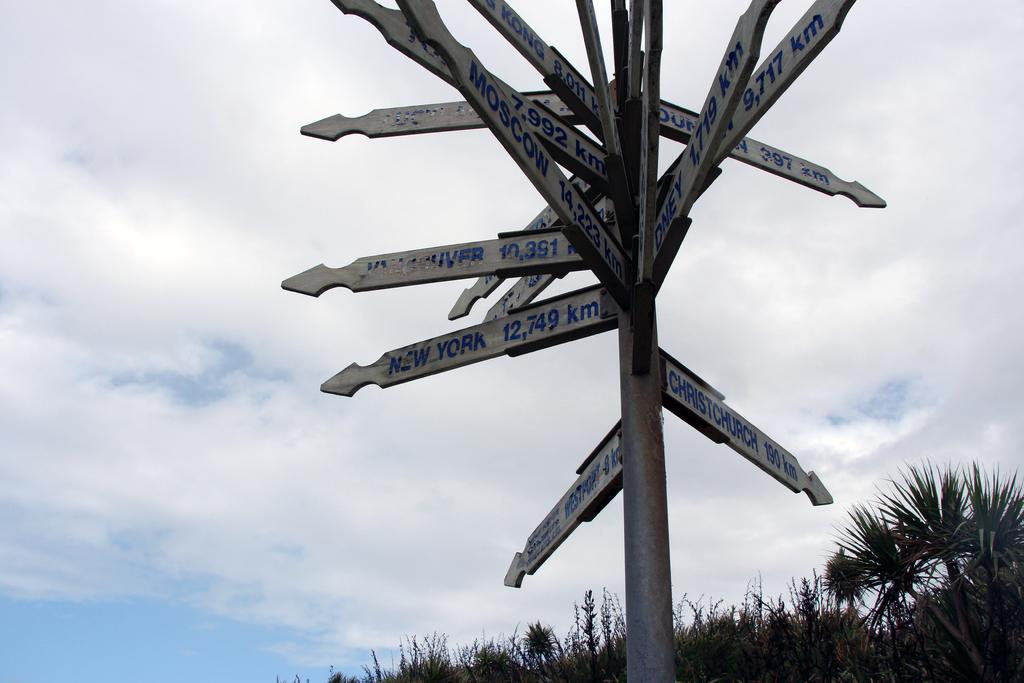Provide a one-sentence caption for the provided image. A post rises into the sky with signposts pointing to Moscow, New York, Christchurch, and many other major cities. 